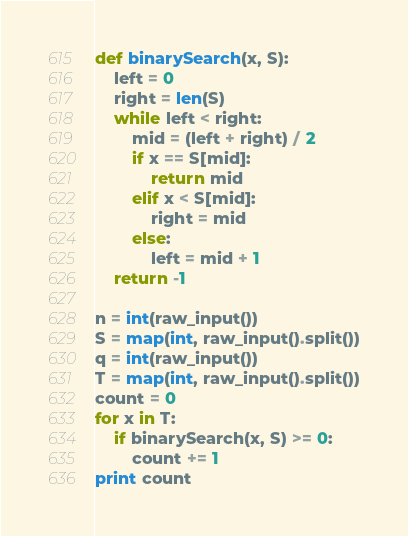Convert code to text. <code><loc_0><loc_0><loc_500><loc_500><_Python_>def binarySearch(x, S):
    left = 0
    right = len(S)
    while left < right:
        mid = (left + right) / 2
        if x == S[mid]:
            return mid
        elif x < S[mid]:
            right = mid
        else:
            left = mid + 1
    return -1

n = int(raw_input())
S = map(int, raw_input().split())
q = int(raw_input())
T = map(int, raw_input().split())
count = 0
for x in T:
    if binarySearch(x, S) >= 0:
        count += 1
print count</code> 